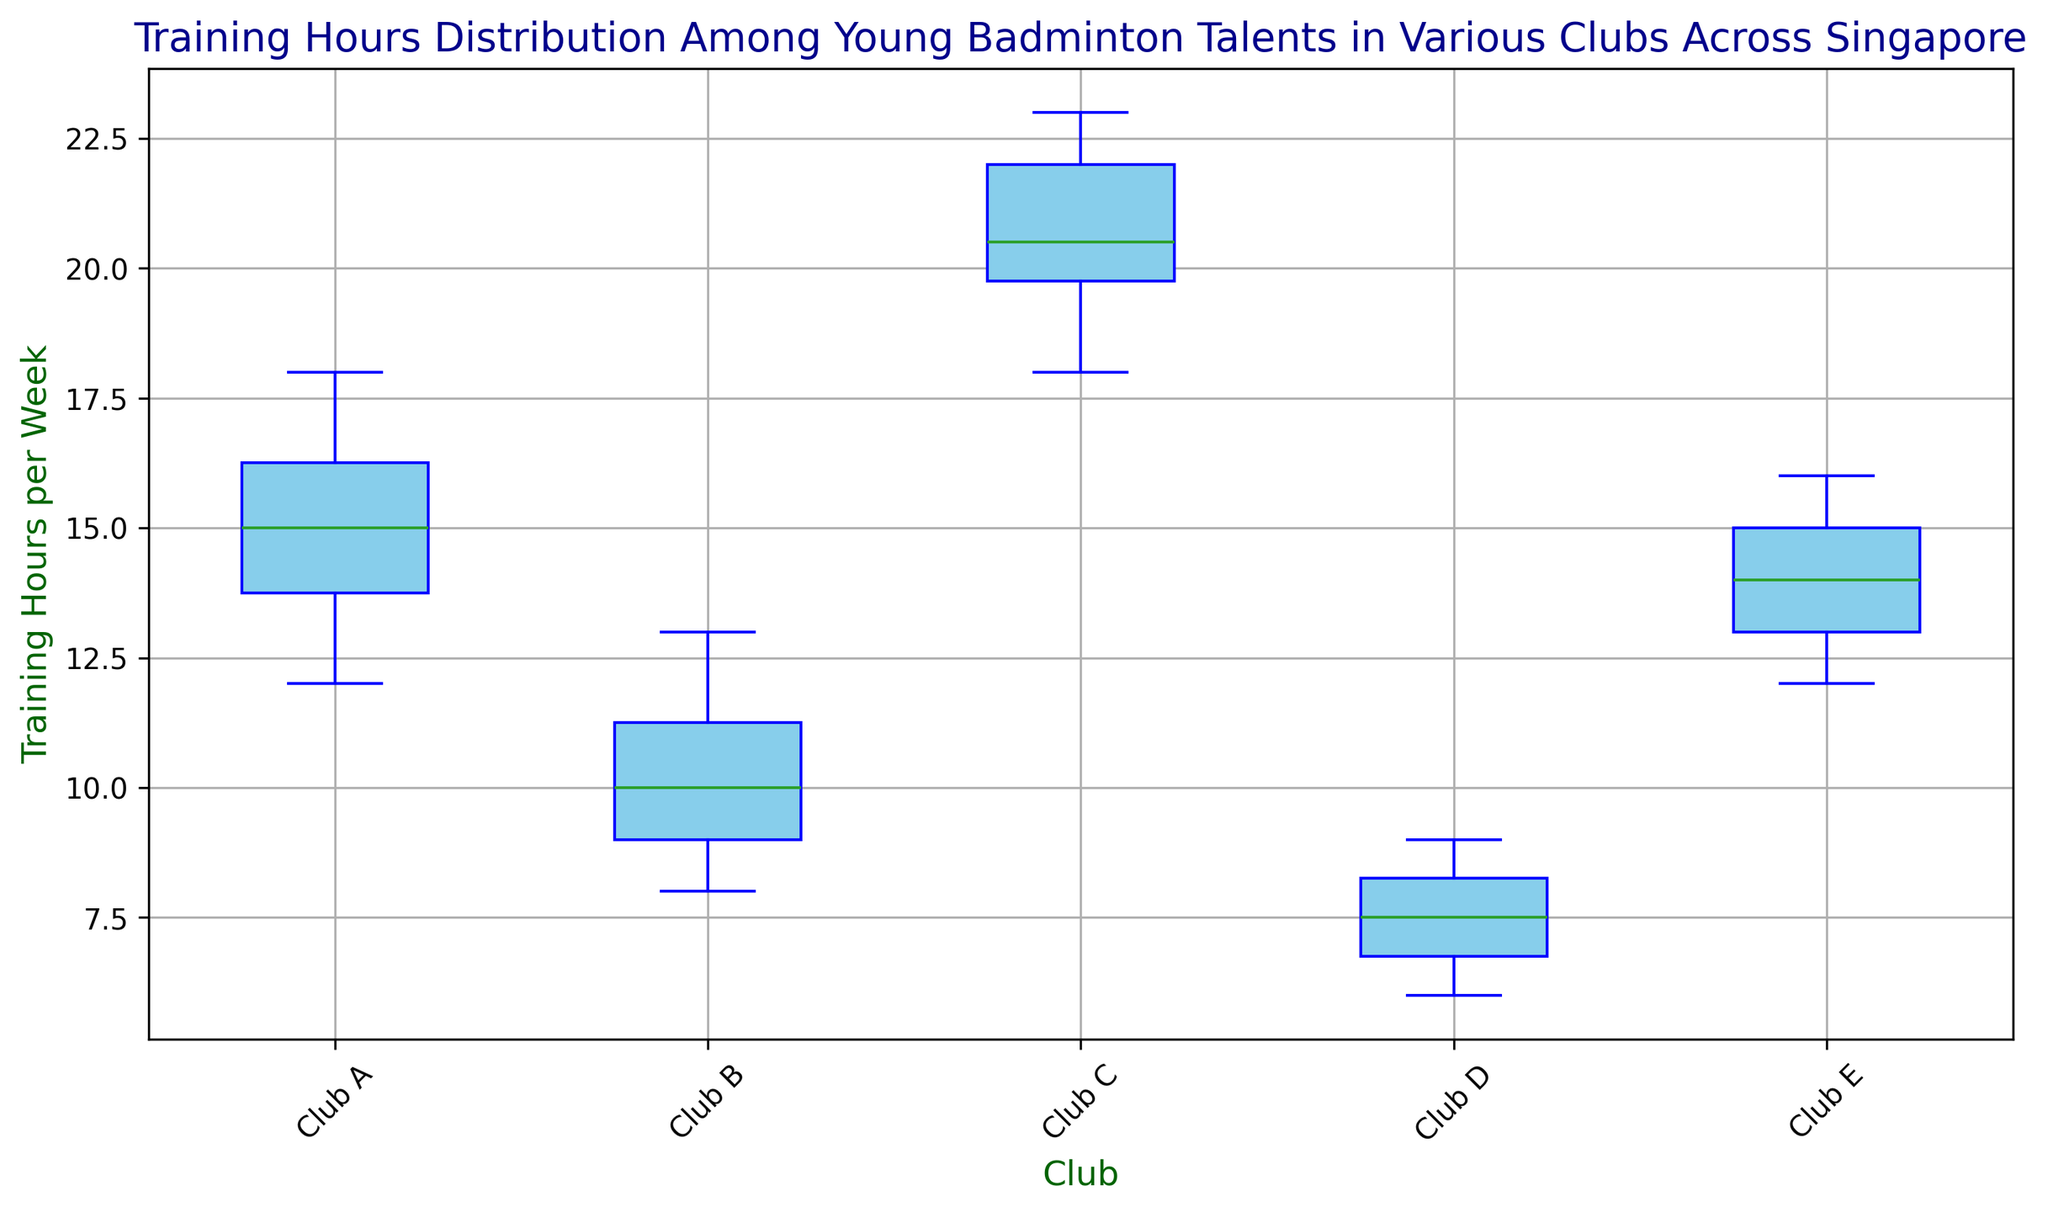What's the median training hours for Club C? The box plot shows the median as the line inside the box for each club. For Club C, this line is located at 20.5 training hours per week.
Answer: 20.5 Which club has the lowest median training hours? Compare the median lines for all clubs. Club D has the lowest one, around 7.5 hours per week.
Answer: Club D What's the range of training hours in Club E? Range is the difference between the maximum and minimum values. For Club E, the whiskers extend from approximately 12 to 16 hours. So, the range is 16 - 12 = 4 hours.
Answer: 4 hours Do any clubs have outliers in their training hours? Outliers are typically shown as individual points outside the whiskers. Club B has outliers with training hours marked as points around 8 and 13 hours.
Answer: Yes, Club B How does the interquartile range (IQR) of Club A compare to that of Club D? The IQR is the distance between the first and third quartiles (the edges of the box). For Club A, the IQR spans from approximately 13 to 17 (IQR = 4). For Club D, it spans from about 7 to 9 (IQR = 2). Club A has a larger IQR (4 vs. 2 hours).
Answer: Club A has a larger IQR Which club shows the highest variability in training hours? Variability can be assessed by the length of the box and the whiskers. Club C shows the highest variability as the whiskers and box span the largest range of values (from approximately 18 to 23 hours).
Answer: Club C What is the first quartile for Club B? The first quartile is at the bottom edge of the box. For Club B, this value is about 9 hours.
Answer: 9 hours Which club has the smallest interquartile range? The smallest interquartile range is found by comparing the box lengths. Club D has the smallest IQR, spanning approximately from 7 to 9 hours (IQR = 2 hours).
Answer: Club D How does the median training hours of Club A compare to that of Club E? The median lines inside the boxes need to be compared. Club A has a median around 15 hours, while Club E has a median also around 14 hours. Club A's median is slightly higher.
Answer: Club A's median is higher What is the maximum training hours recorded for Club C? The top whisker end represents the maximum value. For Club C, the maximum is about 23 hours.
Answer: 23 hours 